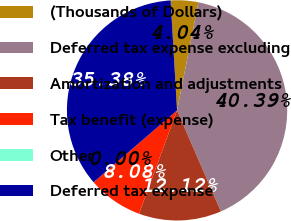Convert chart. <chart><loc_0><loc_0><loc_500><loc_500><pie_chart><fcel>(Thousands of Dollars)<fcel>Deferred tax expense excluding<fcel>Amortization and adjustments<fcel>Tax benefit (expense)<fcel>Other<fcel>Deferred tax expense<nl><fcel>4.04%<fcel>40.39%<fcel>12.12%<fcel>8.08%<fcel>0.0%<fcel>35.38%<nl></chart> 